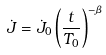Convert formula to latex. <formula><loc_0><loc_0><loc_500><loc_500>\dot { J } = \dot { J } _ { 0 } \left ( \frac { t } { T _ { 0 } } \right ) ^ { - \beta }</formula> 